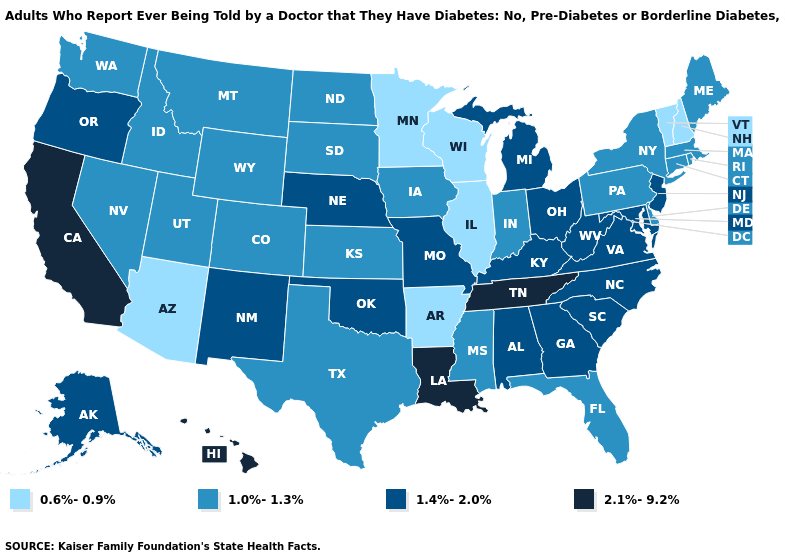What is the value of Connecticut?
Write a very short answer. 1.0%-1.3%. Does the first symbol in the legend represent the smallest category?
Write a very short answer. Yes. What is the value of New Jersey?
Give a very brief answer. 1.4%-2.0%. Does the map have missing data?
Answer briefly. No. What is the value of Indiana?
Write a very short answer. 1.0%-1.3%. What is the highest value in the Northeast ?
Write a very short answer. 1.4%-2.0%. What is the value of New York?
Answer briefly. 1.0%-1.3%. Does New Jersey have the highest value in the Northeast?
Short answer required. Yes. What is the value of Mississippi?
Quick response, please. 1.0%-1.3%. What is the value of South Dakota?
Short answer required. 1.0%-1.3%. What is the lowest value in the USA?
Quick response, please. 0.6%-0.9%. What is the lowest value in states that border Oregon?
Write a very short answer. 1.0%-1.3%. Which states hav the highest value in the MidWest?
Be succinct. Michigan, Missouri, Nebraska, Ohio. Does the map have missing data?
Quick response, please. No. 